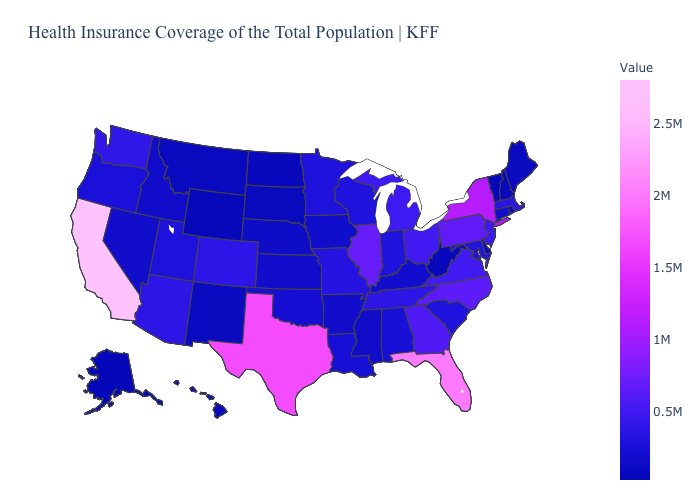Which states have the lowest value in the Northeast?
Answer briefly. Vermont. Which states have the lowest value in the USA?
Answer briefly. Alaska. Among the states that border New Mexico , which have the highest value?
Be succinct. Texas. Does Utah have the lowest value in the West?
Write a very short answer. No. Which states have the highest value in the USA?
Quick response, please. California. 